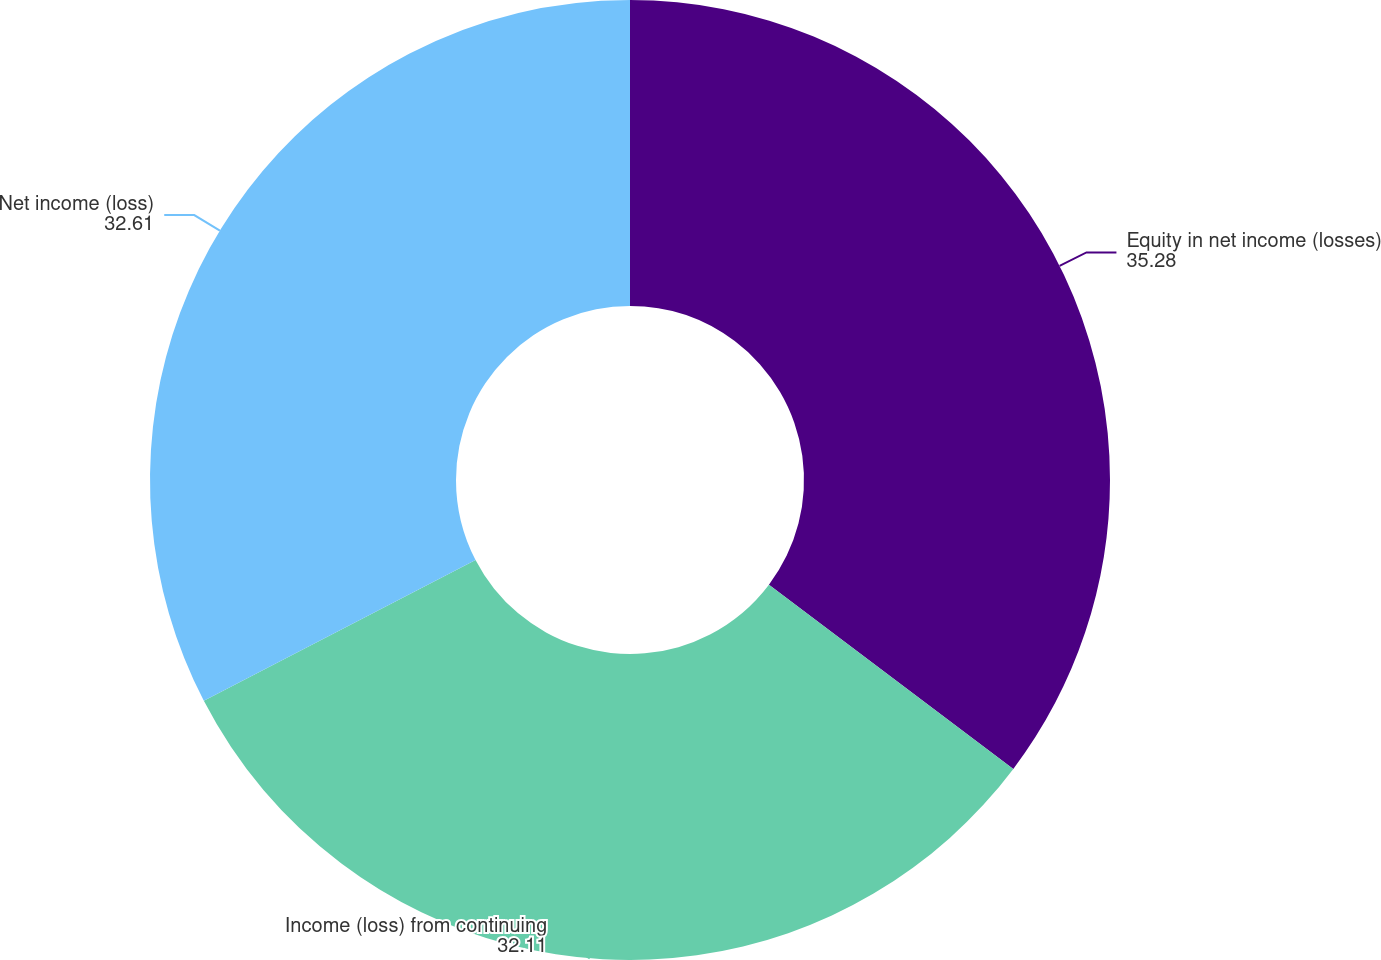Convert chart to OTSL. <chart><loc_0><loc_0><loc_500><loc_500><pie_chart><fcel>Equity in net income (losses)<fcel>Income (loss) from continuing<fcel>Net income (loss)<nl><fcel>35.28%<fcel>32.11%<fcel>32.61%<nl></chart> 